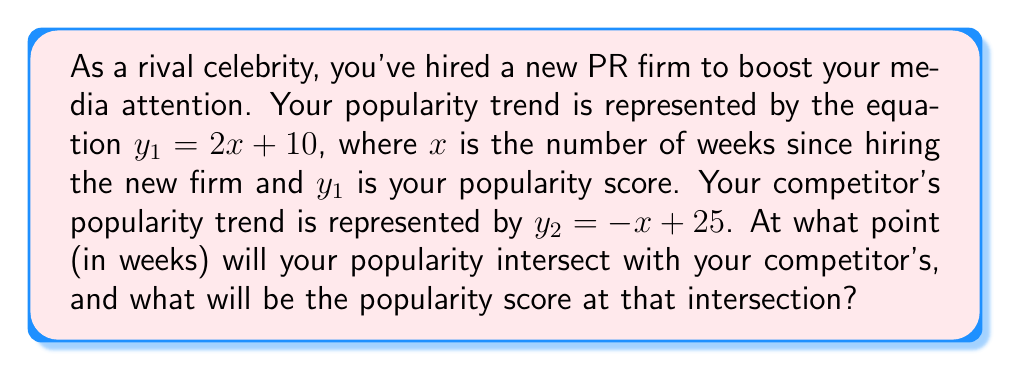Teach me how to tackle this problem. To find the intersection point of these two linear equations, we need to solve for $x$ and $y$ where $y_1 = y_2$:

1) Set the equations equal to each other:
   $2x + 10 = -x + 25$

2) Solve for $x$:
   $2x + 10 = -x + 25$
   $3x = 15$
   $x = 5$

3) Now that we know $x$, we can substitute it into either equation to find $y$. Let's use your equation:
   $y_1 = 2x + 10$
   $y_1 = 2(5) + 10$
   $y_1 = 20$

4) We can verify this by plugging $x = 5$ into your competitor's equation:
   $y_2 = -x + 25$
   $y_2 = -5 + 25$
   $y_2 = 20$

Therefore, the intersection point occurs at $(5, 20)$.
Answer: Your popularity will intersect with your competitor's after 5 weeks, at which point both of you will have a popularity score of 20. 